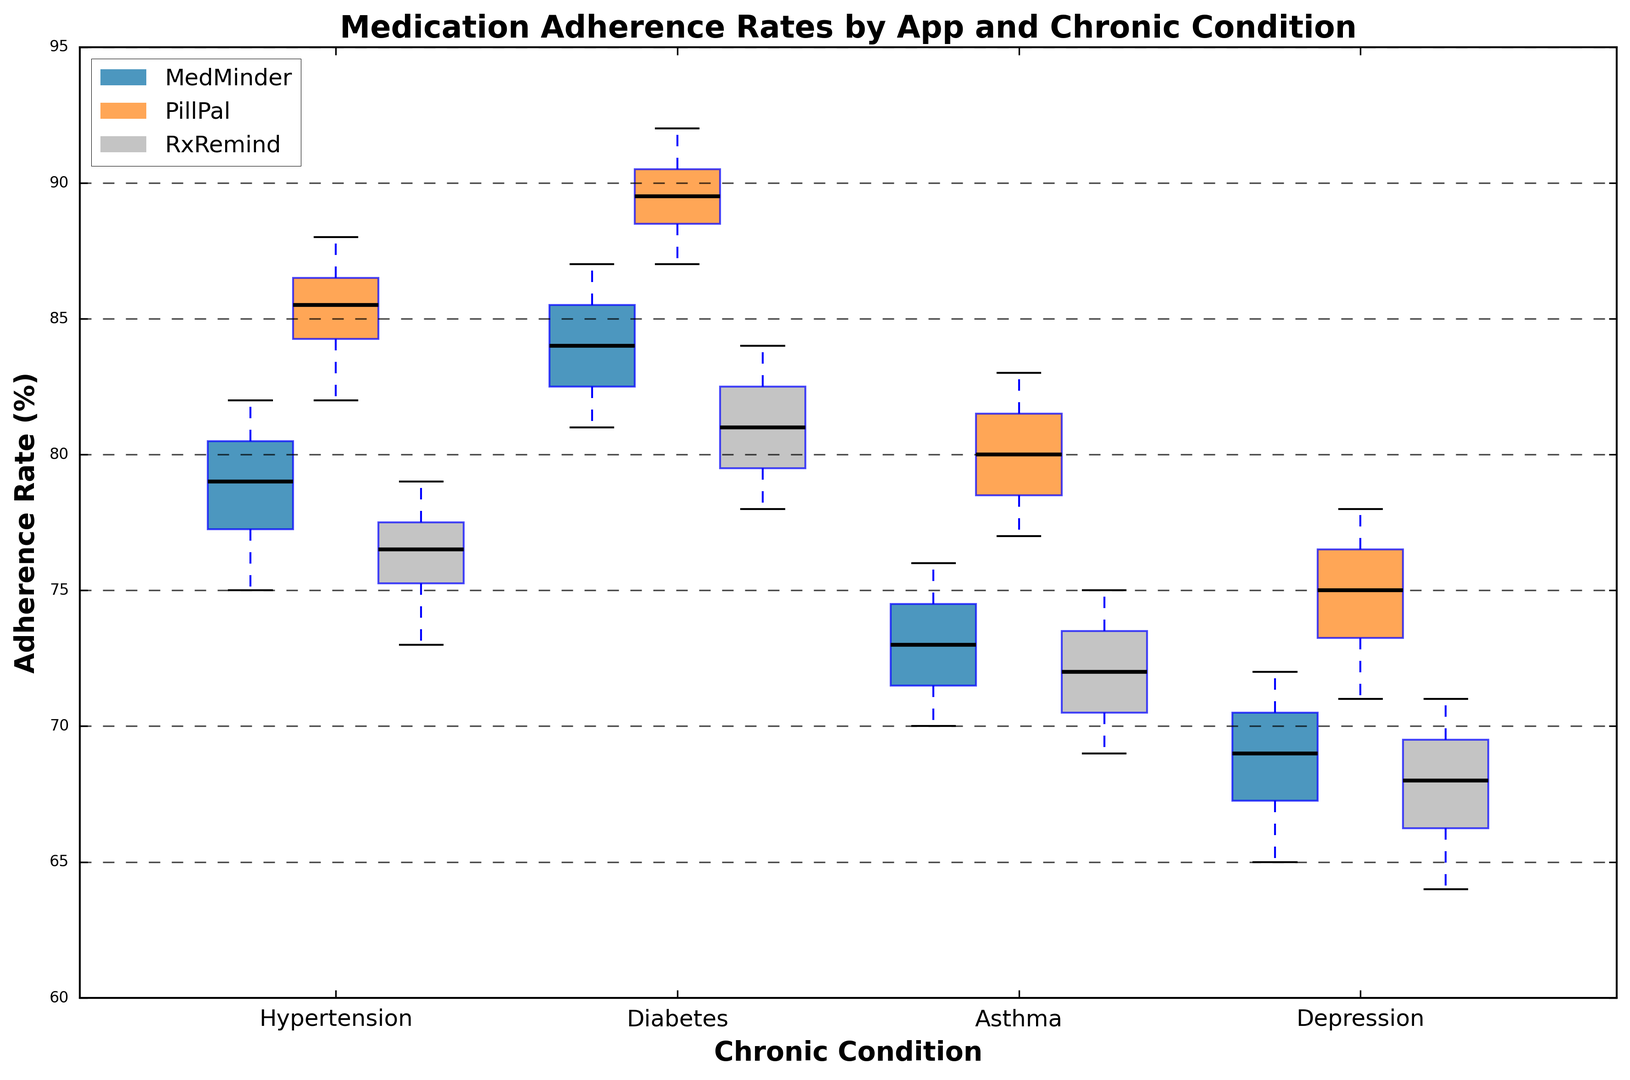What's the median adherence rate for the app RxRemind in patients with Hypertension? To determine the median adherence rate, we look at the box plot for RxRemind under the Hypertension category. The median is the central line within the box.
Answer: 77 Which app has the highest median adherence rate for Diabetes? We compare the central lines in the boxes for each app under the Diabetes category. The highest median is represented by PillPal.
Answer: PillPal Which chronic condition shows the largest interquartile range (IQR) in adherence rates for MedMinder? The IQR is the difference between the upper and lower quartiles (top and bottom of the box). Examine the size of the boxes for MedMinder across conditions. Depression has the largest IQR.
Answer: Depression Between MedMinder and PillPal, which app has a higher median adherence rate for Asthma? We compare the central lines in the boxes for MedMinder and PillPal under the Asthma category. PillPal's median is higher than MedMinder's.
Answer: PillPal What is the spread of adherence rates (range) for RxRemind in Depression? The range is the difference between the highest and lowest values (ends of the whiskers). For RxRemind in Depression, it ranges from 64 to 71.
Answer: 64-71 Which app shows the most consistent adherence rates (smallest IQR) for Diabetes? To find the most consistent app, we look for the smallest IQR (small box) in the Diabetes category. MedMinder shows the smallest IQR.
Answer: MedMinder What is the best-performing app in terms of maximum adherence rate across all conditions? To find this, we check the highest tip of the whiskers across all apps and conditions. PillPal for Diabetes shows the highest maximum value.
Answer: PillPal Compare the median adherence rates between Hypertension and Asthma for PillPal. Which condition has a higher median? We compare the central lines in the boxes for PillPal in Hypertension and Asthma. Hypertension's median is higher than Asthma's.
Answer: Hypertension By observing the plots, which app seems to have the least variability in adherence rates for Hypertension? The least variability is indicated by the smallest IQR (narrowed box). PillPal has the least variability for Hypertension.
Answer: PillPal 